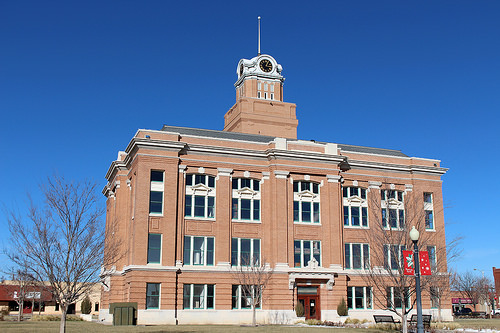<image>
Is the tree behind the building? No. The tree is not behind the building. From this viewpoint, the tree appears to be positioned elsewhere in the scene. 